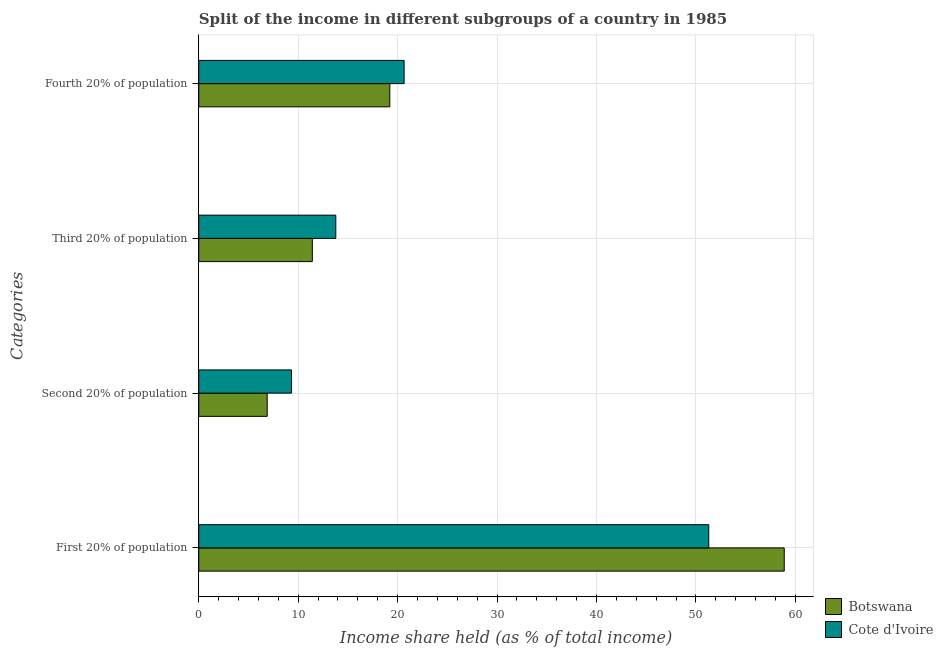How many different coloured bars are there?
Ensure brevity in your answer.  2. Are the number of bars per tick equal to the number of legend labels?
Make the answer very short. Yes. How many bars are there on the 1st tick from the bottom?
Offer a very short reply. 2. What is the label of the 3rd group of bars from the top?
Give a very brief answer. Second 20% of population. What is the share of the income held by third 20% of the population in Cote d'Ivoire?
Your response must be concise. 13.78. Across all countries, what is the maximum share of the income held by second 20% of the population?
Your answer should be compact. 9.33. Across all countries, what is the minimum share of the income held by fourth 20% of the population?
Your answer should be very brief. 19.21. In which country was the share of the income held by third 20% of the population maximum?
Offer a terse response. Cote d'Ivoire. In which country was the share of the income held by third 20% of the population minimum?
Offer a very short reply. Botswana. What is the total share of the income held by second 20% of the population in the graph?
Offer a terse response. 16.21. What is the difference between the share of the income held by third 20% of the population in Botswana and that in Cote d'Ivoire?
Your answer should be very brief. -2.36. What is the difference between the share of the income held by second 20% of the population in Cote d'Ivoire and the share of the income held by first 20% of the population in Botswana?
Make the answer very short. -49.55. What is the average share of the income held by fourth 20% of the population per country?
Keep it short and to the point. 19.93. What is the difference between the share of the income held by third 20% of the population and share of the income held by second 20% of the population in Botswana?
Your response must be concise. 4.54. What is the ratio of the share of the income held by fourth 20% of the population in Botswana to that in Cote d'Ivoire?
Ensure brevity in your answer.  0.93. Is the share of the income held by first 20% of the population in Botswana less than that in Cote d'Ivoire?
Offer a terse response. No. What is the difference between the highest and the second highest share of the income held by second 20% of the population?
Offer a very short reply. 2.45. What is the difference between the highest and the lowest share of the income held by first 20% of the population?
Your response must be concise. 7.59. In how many countries, is the share of the income held by third 20% of the population greater than the average share of the income held by third 20% of the population taken over all countries?
Offer a very short reply. 1. What does the 1st bar from the top in Fourth 20% of population represents?
Provide a succinct answer. Cote d'Ivoire. What does the 1st bar from the bottom in Fourth 20% of population represents?
Your answer should be very brief. Botswana. Is it the case that in every country, the sum of the share of the income held by first 20% of the population and share of the income held by second 20% of the population is greater than the share of the income held by third 20% of the population?
Offer a very short reply. Yes. How many bars are there?
Offer a terse response. 8. Where does the legend appear in the graph?
Your response must be concise. Bottom right. How many legend labels are there?
Give a very brief answer. 2. How are the legend labels stacked?
Give a very brief answer. Vertical. What is the title of the graph?
Your response must be concise. Split of the income in different subgroups of a country in 1985. Does "Monaco" appear as one of the legend labels in the graph?
Make the answer very short. No. What is the label or title of the X-axis?
Keep it short and to the point. Income share held (as % of total income). What is the label or title of the Y-axis?
Give a very brief answer. Categories. What is the Income share held (as % of total income) of Botswana in First 20% of population?
Your answer should be compact. 58.88. What is the Income share held (as % of total income) in Cote d'Ivoire in First 20% of population?
Provide a succinct answer. 51.29. What is the Income share held (as % of total income) in Botswana in Second 20% of population?
Your response must be concise. 6.88. What is the Income share held (as % of total income) of Cote d'Ivoire in Second 20% of population?
Your response must be concise. 9.33. What is the Income share held (as % of total income) of Botswana in Third 20% of population?
Give a very brief answer. 11.42. What is the Income share held (as % of total income) in Cote d'Ivoire in Third 20% of population?
Keep it short and to the point. 13.78. What is the Income share held (as % of total income) in Botswana in Fourth 20% of population?
Your answer should be very brief. 19.21. What is the Income share held (as % of total income) of Cote d'Ivoire in Fourth 20% of population?
Provide a short and direct response. 20.65. Across all Categories, what is the maximum Income share held (as % of total income) of Botswana?
Your answer should be compact. 58.88. Across all Categories, what is the maximum Income share held (as % of total income) of Cote d'Ivoire?
Give a very brief answer. 51.29. Across all Categories, what is the minimum Income share held (as % of total income) of Botswana?
Your answer should be very brief. 6.88. Across all Categories, what is the minimum Income share held (as % of total income) in Cote d'Ivoire?
Offer a very short reply. 9.33. What is the total Income share held (as % of total income) in Botswana in the graph?
Keep it short and to the point. 96.39. What is the total Income share held (as % of total income) of Cote d'Ivoire in the graph?
Give a very brief answer. 95.05. What is the difference between the Income share held (as % of total income) in Cote d'Ivoire in First 20% of population and that in Second 20% of population?
Your answer should be very brief. 41.96. What is the difference between the Income share held (as % of total income) in Botswana in First 20% of population and that in Third 20% of population?
Provide a succinct answer. 47.46. What is the difference between the Income share held (as % of total income) of Cote d'Ivoire in First 20% of population and that in Third 20% of population?
Your answer should be compact. 37.51. What is the difference between the Income share held (as % of total income) of Botswana in First 20% of population and that in Fourth 20% of population?
Ensure brevity in your answer.  39.67. What is the difference between the Income share held (as % of total income) in Cote d'Ivoire in First 20% of population and that in Fourth 20% of population?
Provide a short and direct response. 30.64. What is the difference between the Income share held (as % of total income) in Botswana in Second 20% of population and that in Third 20% of population?
Provide a short and direct response. -4.54. What is the difference between the Income share held (as % of total income) of Cote d'Ivoire in Second 20% of population and that in Third 20% of population?
Offer a terse response. -4.45. What is the difference between the Income share held (as % of total income) of Botswana in Second 20% of population and that in Fourth 20% of population?
Provide a short and direct response. -12.33. What is the difference between the Income share held (as % of total income) of Cote d'Ivoire in Second 20% of population and that in Fourth 20% of population?
Your answer should be very brief. -11.32. What is the difference between the Income share held (as % of total income) in Botswana in Third 20% of population and that in Fourth 20% of population?
Make the answer very short. -7.79. What is the difference between the Income share held (as % of total income) of Cote d'Ivoire in Third 20% of population and that in Fourth 20% of population?
Keep it short and to the point. -6.87. What is the difference between the Income share held (as % of total income) of Botswana in First 20% of population and the Income share held (as % of total income) of Cote d'Ivoire in Second 20% of population?
Your answer should be very brief. 49.55. What is the difference between the Income share held (as % of total income) in Botswana in First 20% of population and the Income share held (as % of total income) in Cote d'Ivoire in Third 20% of population?
Offer a terse response. 45.1. What is the difference between the Income share held (as % of total income) in Botswana in First 20% of population and the Income share held (as % of total income) in Cote d'Ivoire in Fourth 20% of population?
Offer a terse response. 38.23. What is the difference between the Income share held (as % of total income) in Botswana in Second 20% of population and the Income share held (as % of total income) in Cote d'Ivoire in Fourth 20% of population?
Make the answer very short. -13.77. What is the difference between the Income share held (as % of total income) in Botswana in Third 20% of population and the Income share held (as % of total income) in Cote d'Ivoire in Fourth 20% of population?
Your answer should be very brief. -9.23. What is the average Income share held (as % of total income) in Botswana per Categories?
Give a very brief answer. 24.1. What is the average Income share held (as % of total income) of Cote d'Ivoire per Categories?
Offer a terse response. 23.76. What is the difference between the Income share held (as % of total income) of Botswana and Income share held (as % of total income) of Cote d'Ivoire in First 20% of population?
Offer a terse response. 7.59. What is the difference between the Income share held (as % of total income) in Botswana and Income share held (as % of total income) in Cote d'Ivoire in Second 20% of population?
Your answer should be very brief. -2.45. What is the difference between the Income share held (as % of total income) in Botswana and Income share held (as % of total income) in Cote d'Ivoire in Third 20% of population?
Your response must be concise. -2.36. What is the difference between the Income share held (as % of total income) in Botswana and Income share held (as % of total income) in Cote d'Ivoire in Fourth 20% of population?
Offer a terse response. -1.44. What is the ratio of the Income share held (as % of total income) in Botswana in First 20% of population to that in Second 20% of population?
Provide a succinct answer. 8.56. What is the ratio of the Income share held (as % of total income) of Cote d'Ivoire in First 20% of population to that in Second 20% of population?
Make the answer very short. 5.5. What is the ratio of the Income share held (as % of total income) of Botswana in First 20% of population to that in Third 20% of population?
Your response must be concise. 5.16. What is the ratio of the Income share held (as % of total income) of Cote d'Ivoire in First 20% of population to that in Third 20% of population?
Give a very brief answer. 3.72. What is the ratio of the Income share held (as % of total income) of Botswana in First 20% of population to that in Fourth 20% of population?
Ensure brevity in your answer.  3.07. What is the ratio of the Income share held (as % of total income) in Cote d'Ivoire in First 20% of population to that in Fourth 20% of population?
Provide a succinct answer. 2.48. What is the ratio of the Income share held (as % of total income) of Botswana in Second 20% of population to that in Third 20% of population?
Give a very brief answer. 0.6. What is the ratio of the Income share held (as % of total income) of Cote d'Ivoire in Second 20% of population to that in Third 20% of population?
Your response must be concise. 0.68. What is the ratio of the Income share held (as % of total income) of Botswana in Second 20% of population to that in Fourth 20% of population?
Give a very brief answer. 0.36. What is the ratio of the Income share held (as % of total income) in Cote d'Ivoire in Second 20% of population to that in Fourth 20% of population?
Offer a terse response. 0.45. What is the ratio of the Income share held (as % of total income) in Botswana in Third 20% of population to that in Fourth 20% of population?
Ensure brevity in your answer.  0.59. What is the ratio of the Income share held (as % of total income) of Cote d'Ivoire in Third 20% of population to that in Fourth 20% of population?
Your answer should be very brief. 0.67. What is the difference between the highest and the second highest Income share held (as % of total income) of Botswana?
Your answer should be compact. 39.67. What is the difference between the highest and the second highest Income share held (as % of total income) of Cote d'Ivoire?
Give a very brief answer. 30.64. What is the difference between the highest and the lowest Income share held (as % of total income) in Botswana?
Ensure brevity in your answer.  52. What is the difference between the highest and the lowest Income share held (as % of total income) in Cote d'Ivoire?
Offer a terse response. 41.96. 